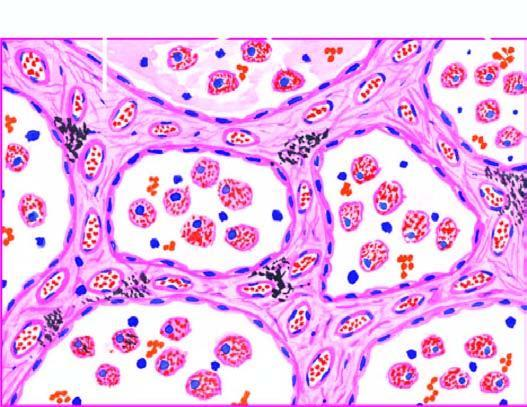re the alveolar septa widened and thickened due to congestion, oedema and mild fibrosis?
Answer the question using a single word or phrase. Yes 